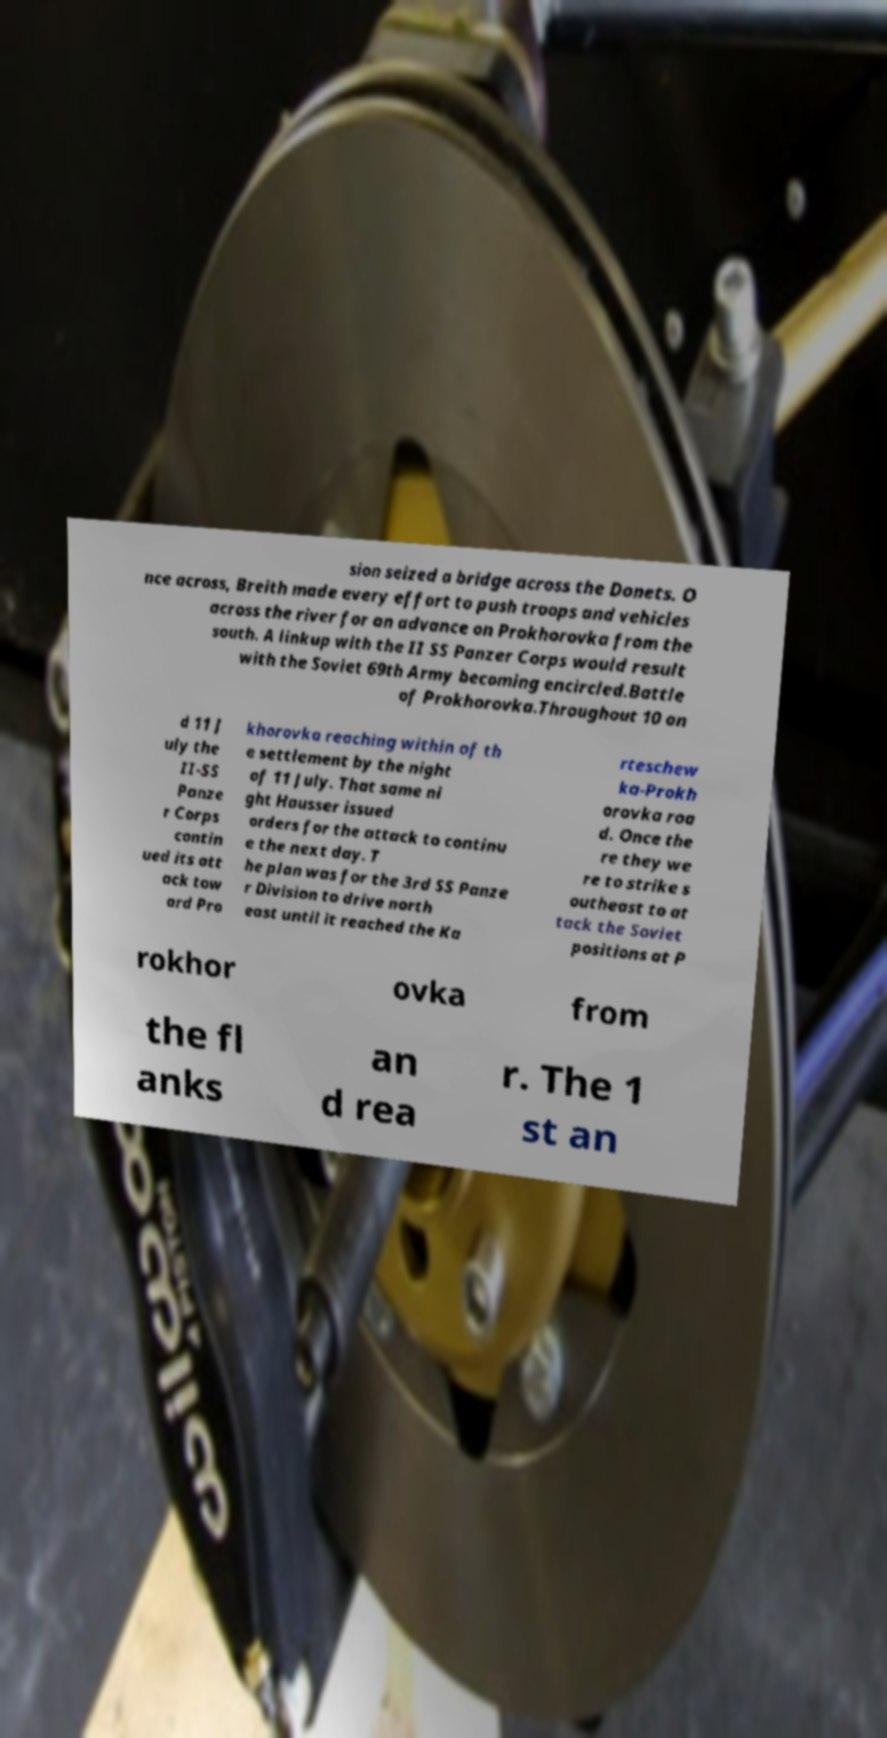Can you read and provide the text displayed in the image?This photo seems to have some interesting text. Can you extract and type it out for me? sion seized a bridge across the Donets. O nce across, Breith made every effort to push troops and vehicles across the river for an advance on Prokhorovka from the south. A linkup with the II SS Panzer Corps would result with the Soviet 69th Army becoming encircled.Battle of Prokhorovka.Throughout 10 an d 11 J uly the II-SS Panze r Corps contin ued its att ack tow ard Pro khorovka reaching within of th e settlement by the night of 11 July. That same ni ght Hausser issued orders for the attack to continu e the next day. T he plan was for the 3rd SS Panze r Division to drive north east until it reached the Ka rteschew ka-Prokh orovka roa d. Once the re they we re to strike s outheast to at tack the Soviet positions at P rokhor ovka from the fl anks an d rea r. The 1 st an 